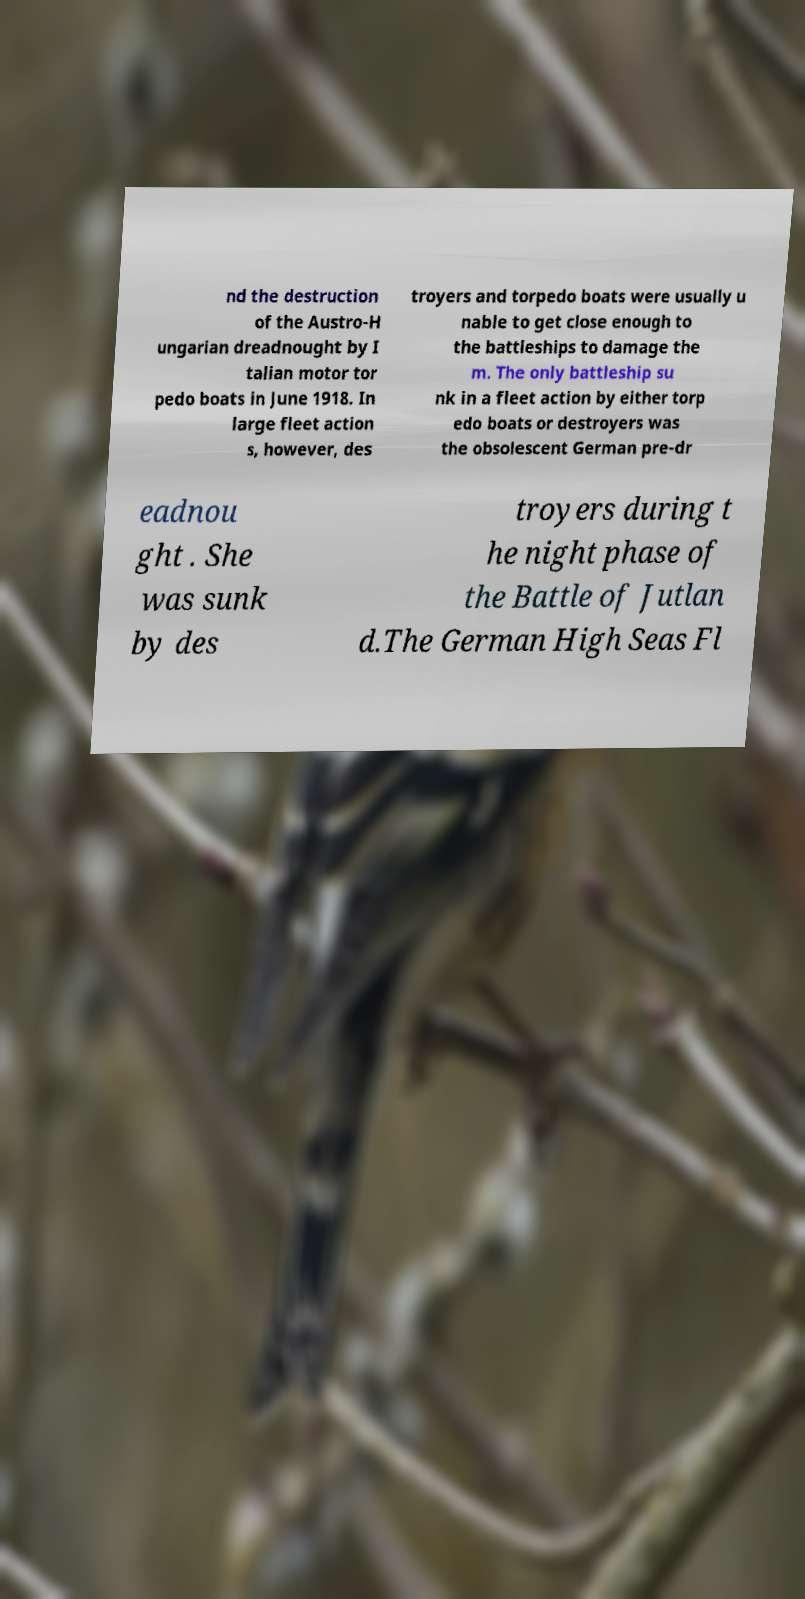Could you assist in decoding the text presented in this image and type it out clearly? nd the destruction of the Austro-H ungarian dreadnought by I talian motor tor pedo boats in June 1918. In large fleet action s, however, des troyers and torpedo boats were usually u nable to get close enough to the battleships to damage the m. The only battleship su nk in a fleet action by either torp edo boats or destroyers was the obsolescent German pre-dr eadnou ght . She was sunk by des troyers during t he night phase of the Battle of Jutlan d.The German High Seas Fl 